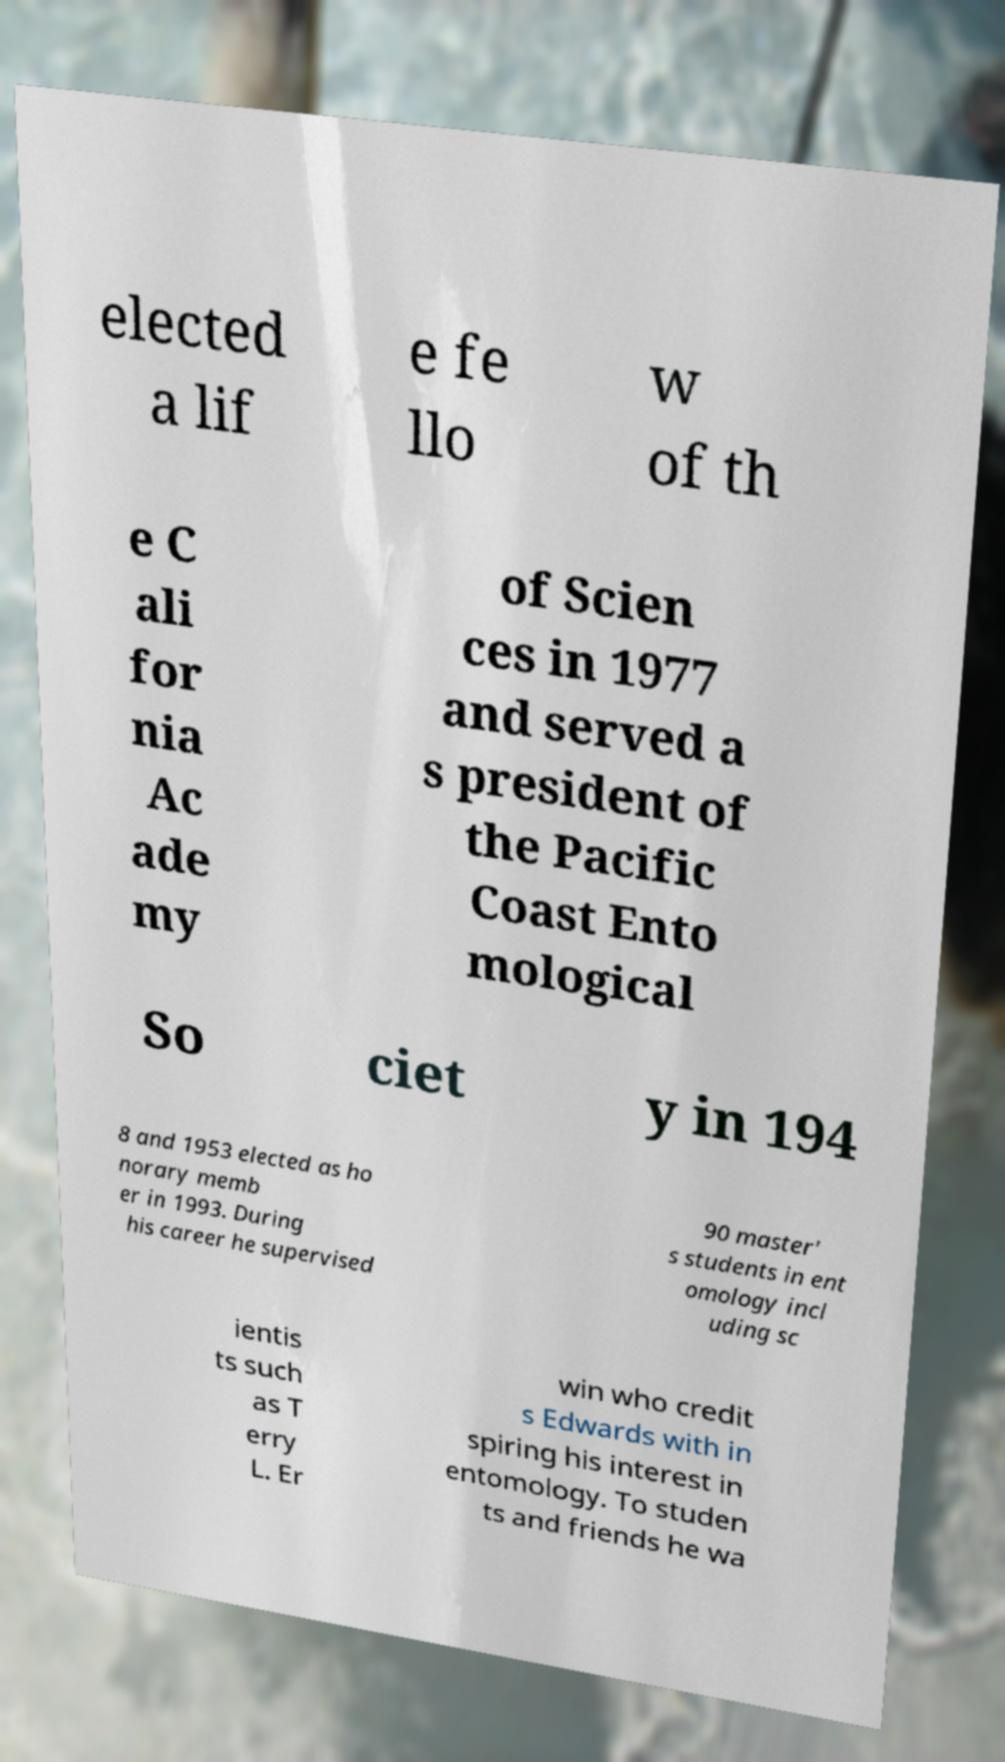Please identify and transcribe the text found in this image. elected a lif e fe llo w of th e C ali for nia Ac ade my of Scien ces in 1977 and served a s president of the Pacific Coast Ento mological So ciet y in 194 8 and 1953 elected as ho norary memb er in 1993. During his career he supervised 90 master' s students in ent omology incl uding sc ientis ts such as T erry L. Er win who credit s Edwards with in spiring his interest in entomology. To studen ts and friends he wa 